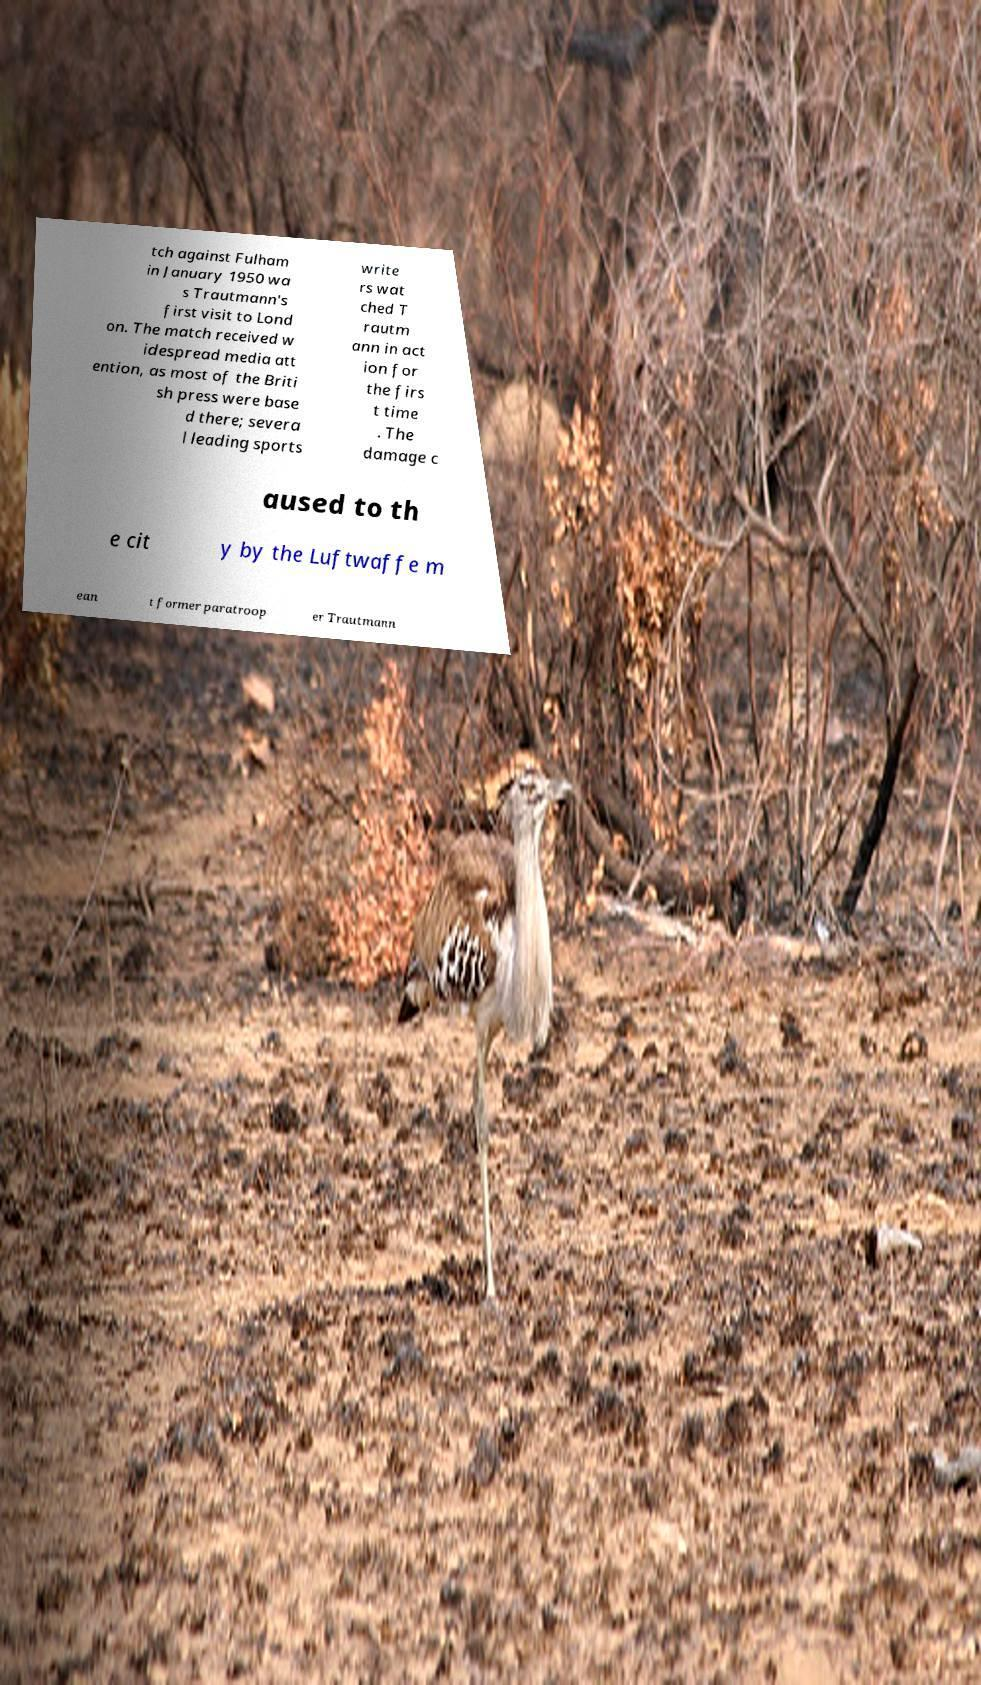Could you extract and type out the text from this image? tch against Fulham in January 1950 wa s Trautmann's first visit to Lond on. The match received w idespread media att ention, as most of the Briti sh press were base d there; severa l leading sports write rs wat ched T rautm ann in act ion for the firs t time . The damage c aused to th e cit y by the Luftwaffe m ean t former paratroop er Trautmann 